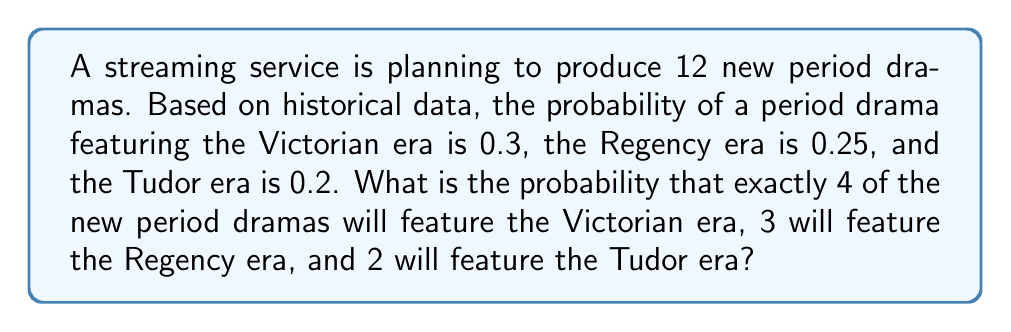Solve this math problem. To solve this problem, we'll use the multinomial distribution, which is appropriate for situations with multiple outcomes.

Step 1: Identify the parameters
- Total number of trials (n) = 12
- Number of Victorian era dramas (k₁) = 4
- Number of Regency era dramas (k₂) = 3
- Number of Tudor era dramas (k₃) = 2
- Probability of Victorian era (p₁) = 0.3
- Probability of Regency era (p₂) = 0.25
- Probability of Tudor era (p₃) = 0.2
- Probability of other eras (p₄) = 1 - (0.3 + 0.25 + 0.2) = 0.25
- Number of other era dramas (k₄) = 12 - (4 + 3 + 2) = 3

Step 2: Apply the multinomial probability formula
$$P(X_1=k_1, X_2=k_2, X_3=k_3, X_4=k_4) = \frac{n!}{k_1!k_2!k_3!k_4!} p_1^{k_1} p_2^{k_2} p_3^{k_3} p_4^{k_4}$$

Step 3: Substitute the values
$$P(X_1=4, X_2=3, X_3=2, X_4=3) = \frac{12!}{4!3!2!3!} (0.3)^4 (0.25)^3 (0.2)^2 (0.25)^3$$

Step 4: Calculate
$$\begin{aligned}
P &= \frac{12!}{4!3!2!3!} (0.3)^4 (0.25)^3 (0.2)^2 (0.25)^3 \\
&= 369,600 \times 0.0081 \times 0.015625 \times 0.04 \times 0.015625 \\
&\approx 0.0138
\end{aligned}$$
Answer: $0.0138$ or $1.38\%$ 